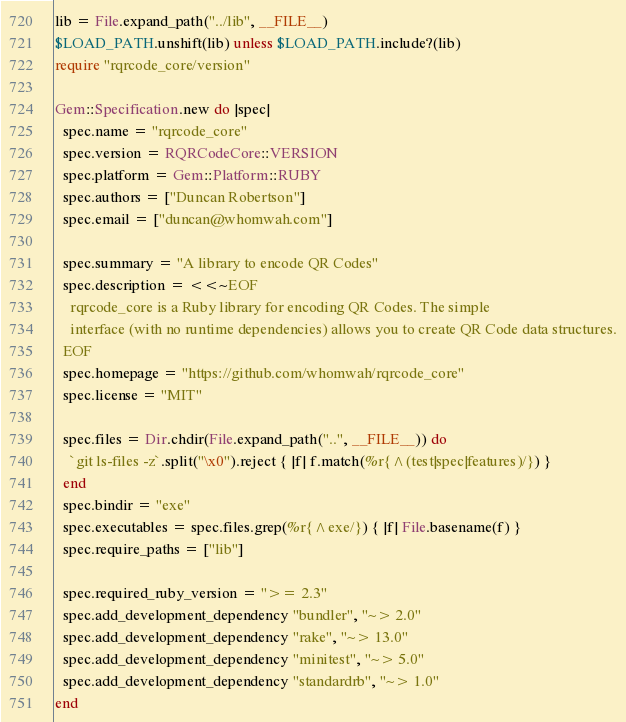Convert code to text. <code><loc_0><loc_0><loc_500><loc_500><_Ruby_>lib = File.expand_path("../lib", __FILE__)
$LOAD_PATH.unshift(lib) unless $LOAD_PATH.include?(lib)
require "rqrcode_core/version"

Gem::Specification.new do |spec|
  spec.name = "rqrcode_core"
  spec.version = RQRCodeCore::VERSION
  spec.platform = Gem::Platform::RUBY
  spec.authors = ["Duncan Robertson"]
  spec.email = ["duncan@whomwah.com"]

  spec.summary = "A library to encode QR Codes"
  spec.description = <<~EOF
    rqrcode_core is a Ruby library for encoding QR Codes. The simple
    interface (with no runtime dependencies) allows you to create QR Code data structures.
  EOF
  spec.homepage = "https://github.com/whomwah/rqrcode_core"
  spec.license = "MIT"

  spec.files = Dir.chdir(File.expand_path("..", __FILE__)) do
    `git ls-files -z`.split("\x0").reject { |f| f.match(%r{^(test|spec|features)/}) }
  end
  spec.bindir = "exe"
  spec.executables = spec.files.grep(%r{^exe/}) { |f| File.basename(f) }
  spec.require_paths = ["lib"]

  spec.required_ruby_version = ">= 2.3"
  spec.add_development_dependency "bundler", "~> 2.0"
  spec.add_development_dependency "rake", "~> 13.0"
  spec.add_development_dependency "minitest", "~> 5.0"
  spec.add_development_dependency "standardrb", "~> 1.0"
end
</code> 